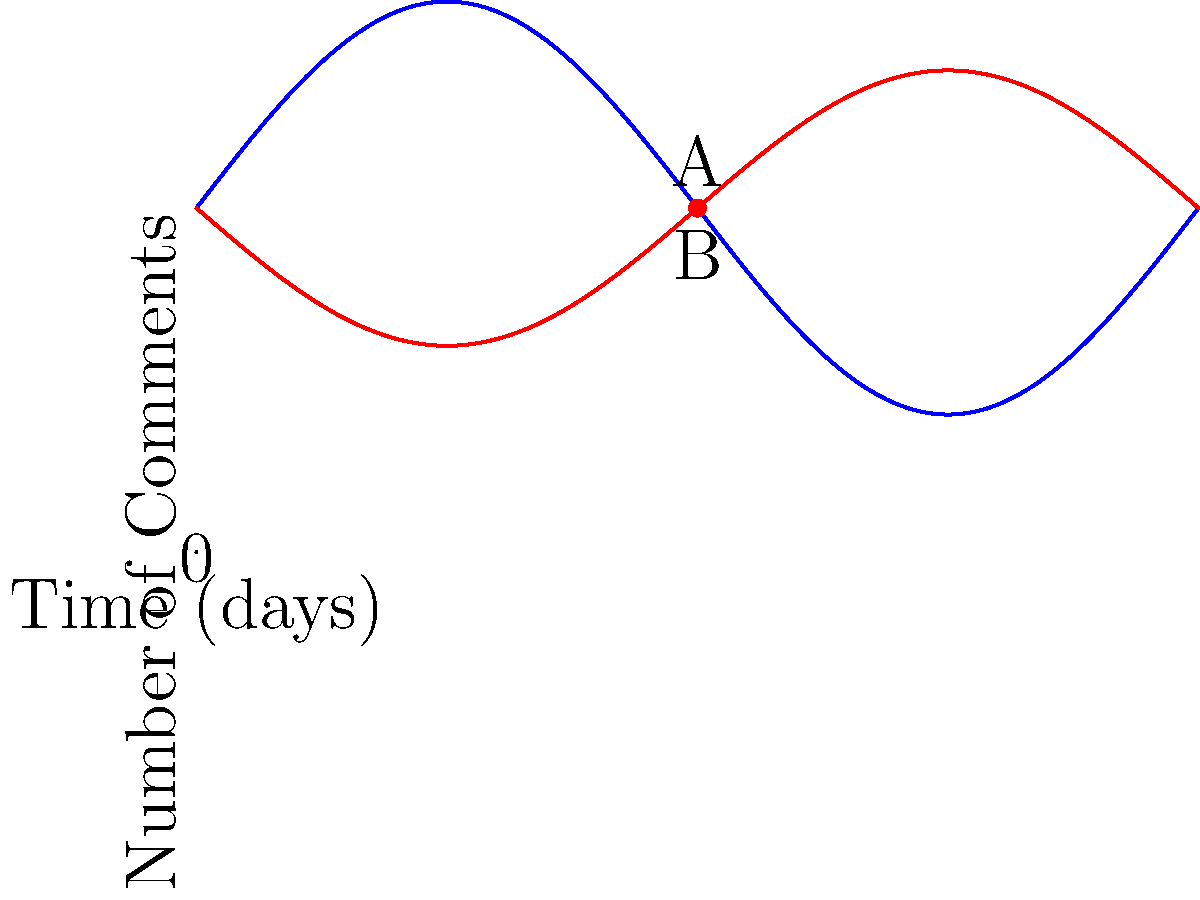The graph shows the number of positive and negative comments on a brand's Instagram posts over time. At point A, the number of positive comments is approximately 20, and at point B, the number of negative comments is about 70. What is the estimated brand sentiment at this point in time? To estimate the brand sentiment, we need to compare the number of positive and negative comments:

1. Identify the number of positive comments (point A): 20
2. Identify the number of negative comments (point B): 70
3. Calculate the total number of comments: 20 + 70 = 90
4. Calculate the percentage of positive comments: (20 / 90) * 100 = 22.22%
5. Calculate the percentage of negative comments: (70 / 90) * 100 = 77.78%
6. Compare the percentages: 77.78% negative > 22.22% positive

The brand sentiment is predominantly negative, with about 3.5 times more negative comments than positive ones.

To quantify this, we can calculate a sentiment score:
Sentiment score = (Positive comments - Negative comments) / Total comments
Sentiment score = (20 - 70) / 90 = -0.56

The sentiment score ranges from -1 (entirely negative) to +1 (entirely positive). A score of -0.56 indicates a significantly negative sentiment.
Answer: Significantly negative (-0.56) 